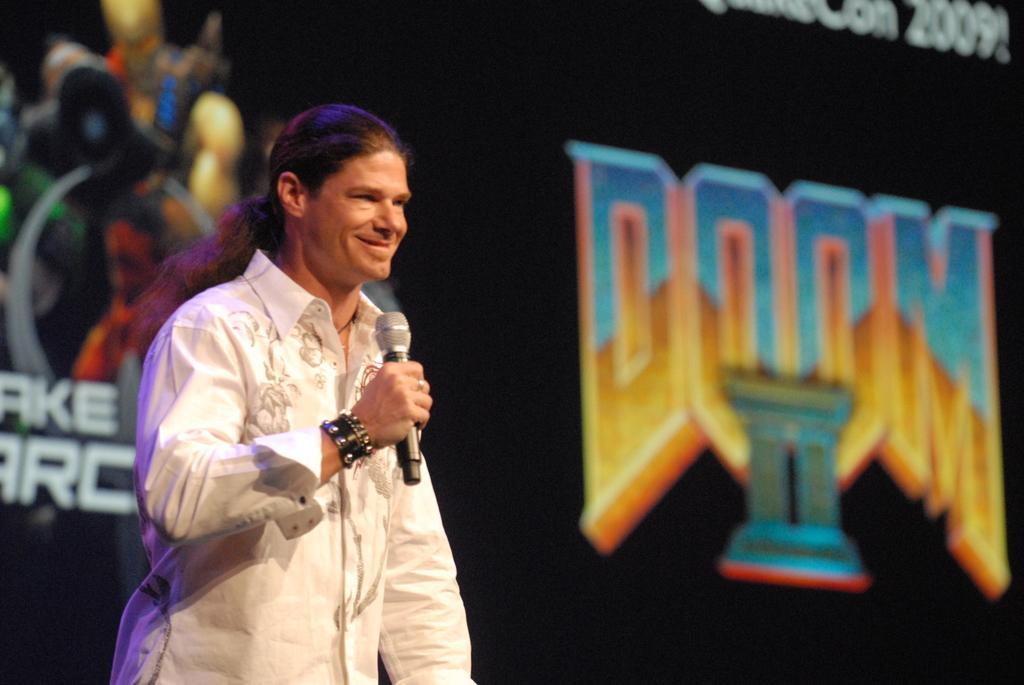Can you describe this image briefly? In this image we can see a person is standing and wore a white color dress and holding a mike in his hand. In the background of the image we can see a poster on which some text was written but it is in a blur. 